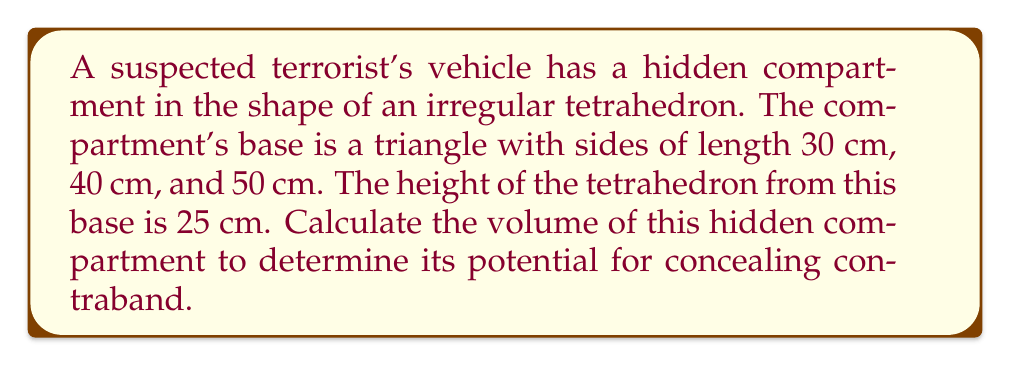Can you answer this question? To solve this problem, we'll follow these steps:

1) First, we need to calculate the area of the base triangle using Heron's formula:

   Let $s$ be the semi-perimeter of the triangle:
   $$s = \frac{a + b + c}{2} = \frac{30 + 40 + 50}{2} = 60\text{ cm}$$

   Heron's formula:
   $$A = \sqrt{s(s-a)(s-b)(s-c)}$$

   where $A$ is the area, and $a$, $b$, and $c$ are the side lengths.

2) Substituting the values:
   $$A = \sqrt{60(60-30)(60-40)(60-50)}$$
   $$A = \sqrt{60 \cdot 30 \cdot 20 \cdot 10}$$
   $$A = \sqrt{360000} = 600\text{ cm}^2$$

3) Now that we have the base area, we can use the formula for the volume of a tetrahedron:
   $$V = \frac{1}{3} \cdot B \cdot h$$

   where $V$ is the volume, $B$ is the area of the base, and $h$ is the height.

4) Substituting our values:
   $$V = \frac{1}{3} \cdot 600 \cdot 25 = 5000\text{ cm}^3$$

Therefore, the volume of the hidden compartment is 5000 cubic centimeters.
Answer: 5000 cm³ 